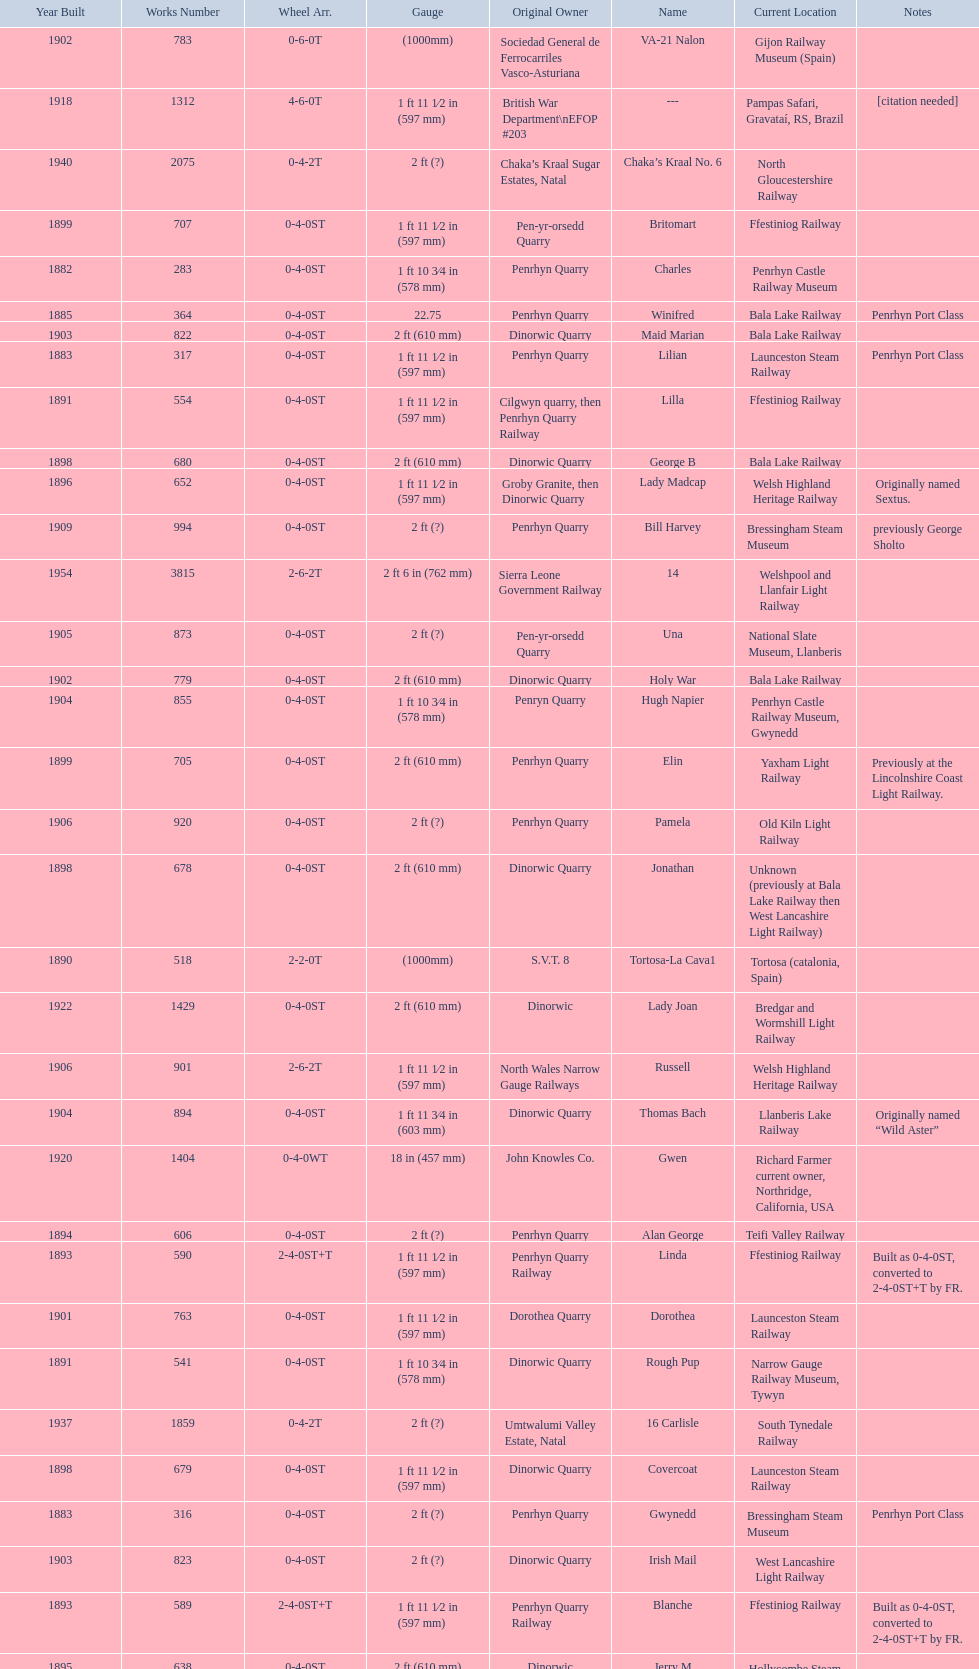What is the works number of the only item built in 1882? 283. 